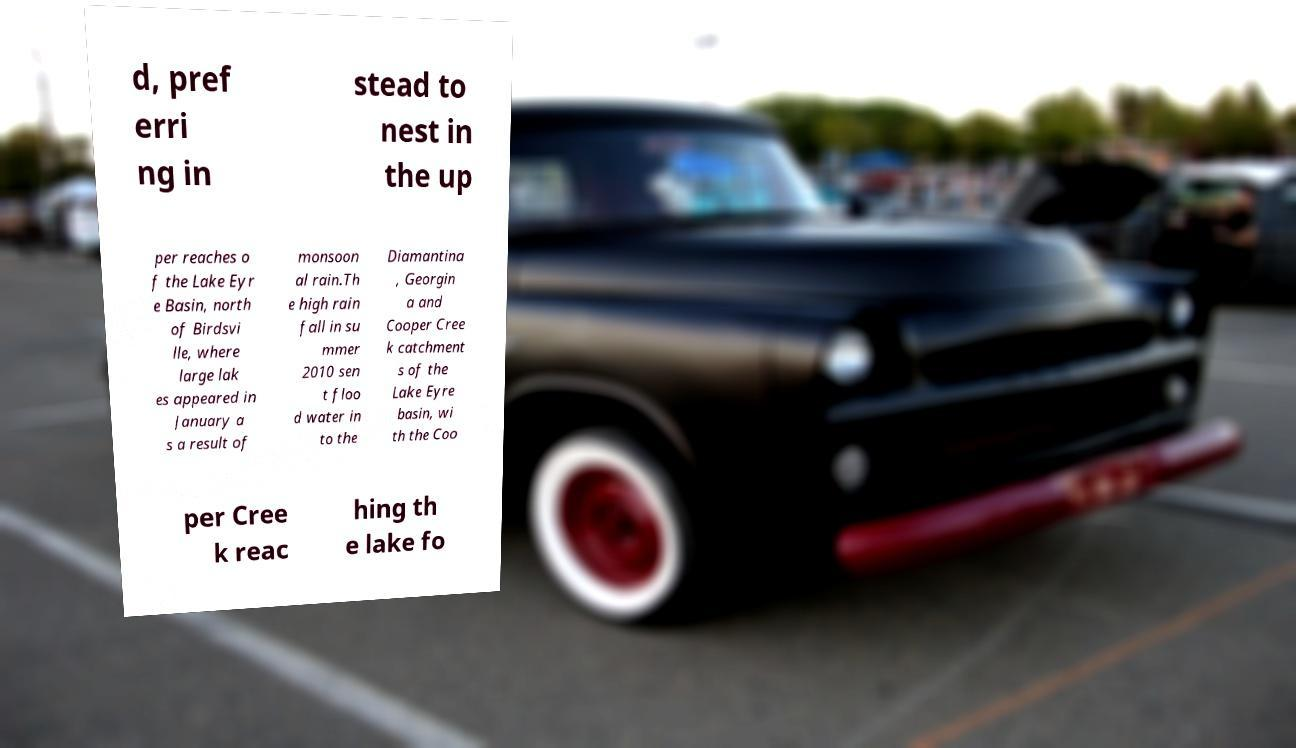Can you read and provide the text displayed in the image?This photo seems to have some interesting text. Can you extract and type it out for me? d, pref erri ng in stead to nest in the up per reaches o f the Lake Eyr e Basin, north of Birdsvi lle, where large lak es appeared in January a s a result of monsoon al rain.Th e high rain fall in su mmer 2010 sen t floo d water in to the Diamantina , Georgin a and Cooper Cree k catchment s of the Lake Eyre basin, wi th the Coo per Cree k reac hing th e lake fo 